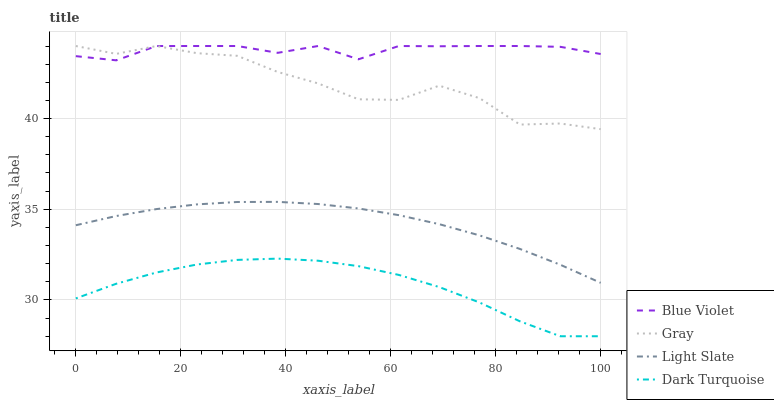Does Dark Turquoise have the minimum area under the curve?
Answer yes or no. Yes. Does Blue Violet have the maximum area under the curve?
Answer yes or no. Yes. Does Gray have the minimum area under the curve?
Answer yes or no. No. Does Gray have the maximum area under the curve?
Answer yes or no. No. Is Light Slate the smoothest?
Answer yes or no. Yes. Is Gray the roughest?
Answer yes or no. Yes. Is Blue Violet the smoothest?
Answer yes or no. No. Is Blue Violet the roughest?
Answer yes or no. No. Does Dark Turquoise have the lowest value?
Answer yes or no. Yes. Does Gray have the lowest value?
Answer yes or no. No. Does Blue Violet have the highest value?
Answer yes or no. Yes. Does Dark Turquoise have the highest value?
Answer yes or no. No. Is Dark Turquoise less than Light Slate?
Answer yes or no. Yes. Is Blue Violet greater than Dark Turquoise?
Answer yes or no. Yes. Does Gray intersect Blue Violet?
Answer yes or no. Yes. Is Gray less than Blue Violet?
Answer yes or no. No. Is Gray greater than Blue Violet?
Answer yes or no. No. Does Dark Turquoise intersect Light Slate?
Answer yes or no. No. 